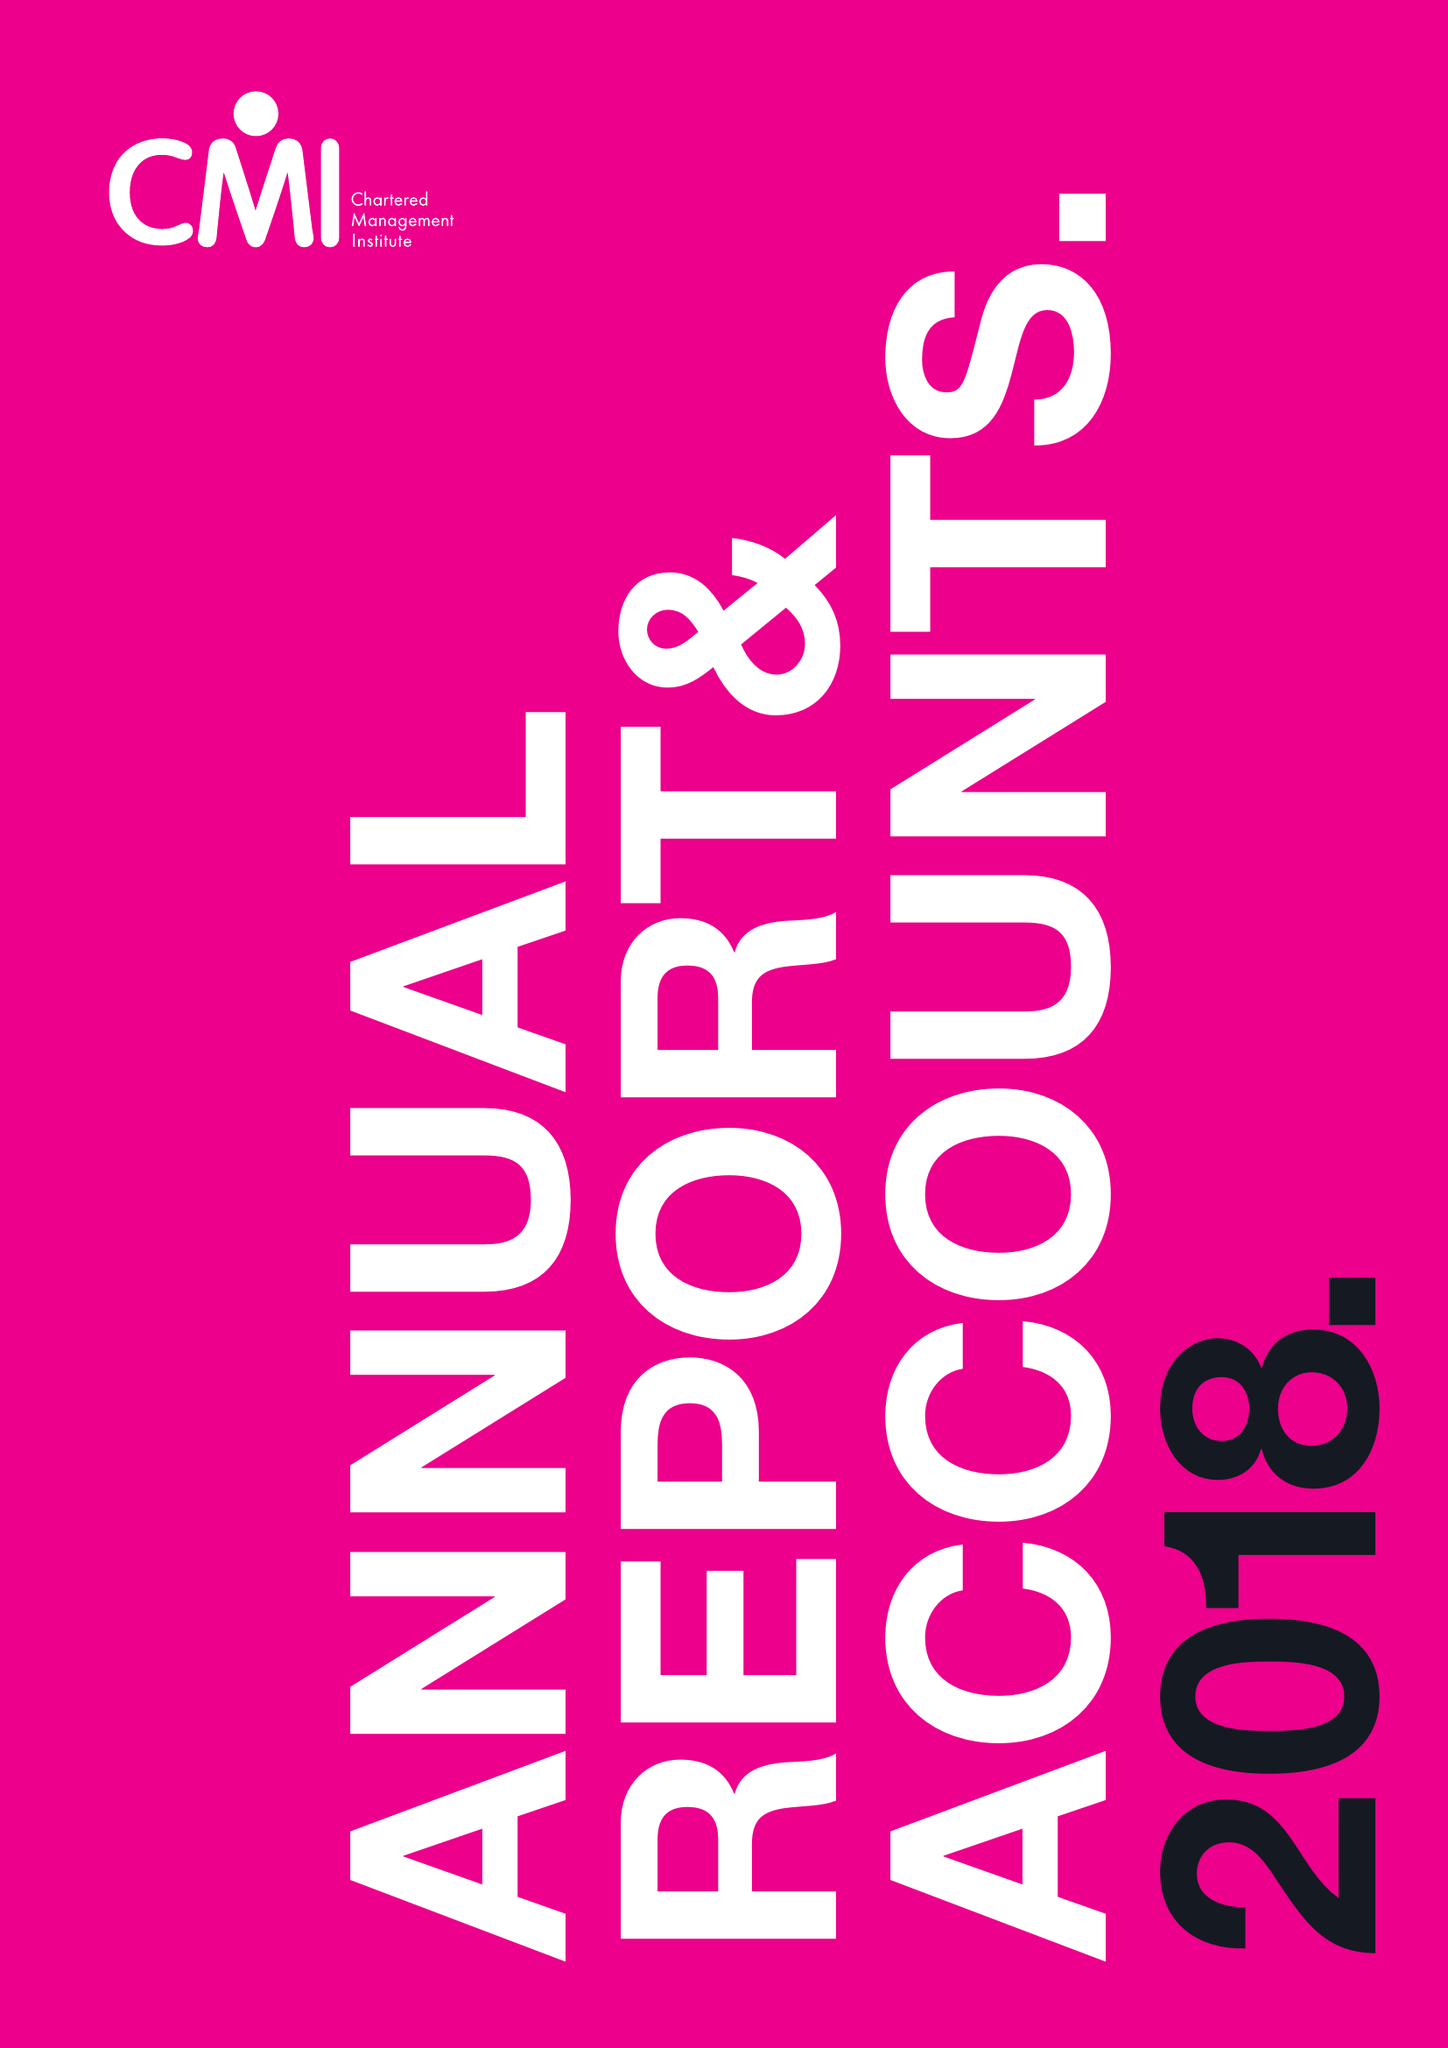What is the value for the address__post_town?
Answer the question using a single word or phrase. CORBY 